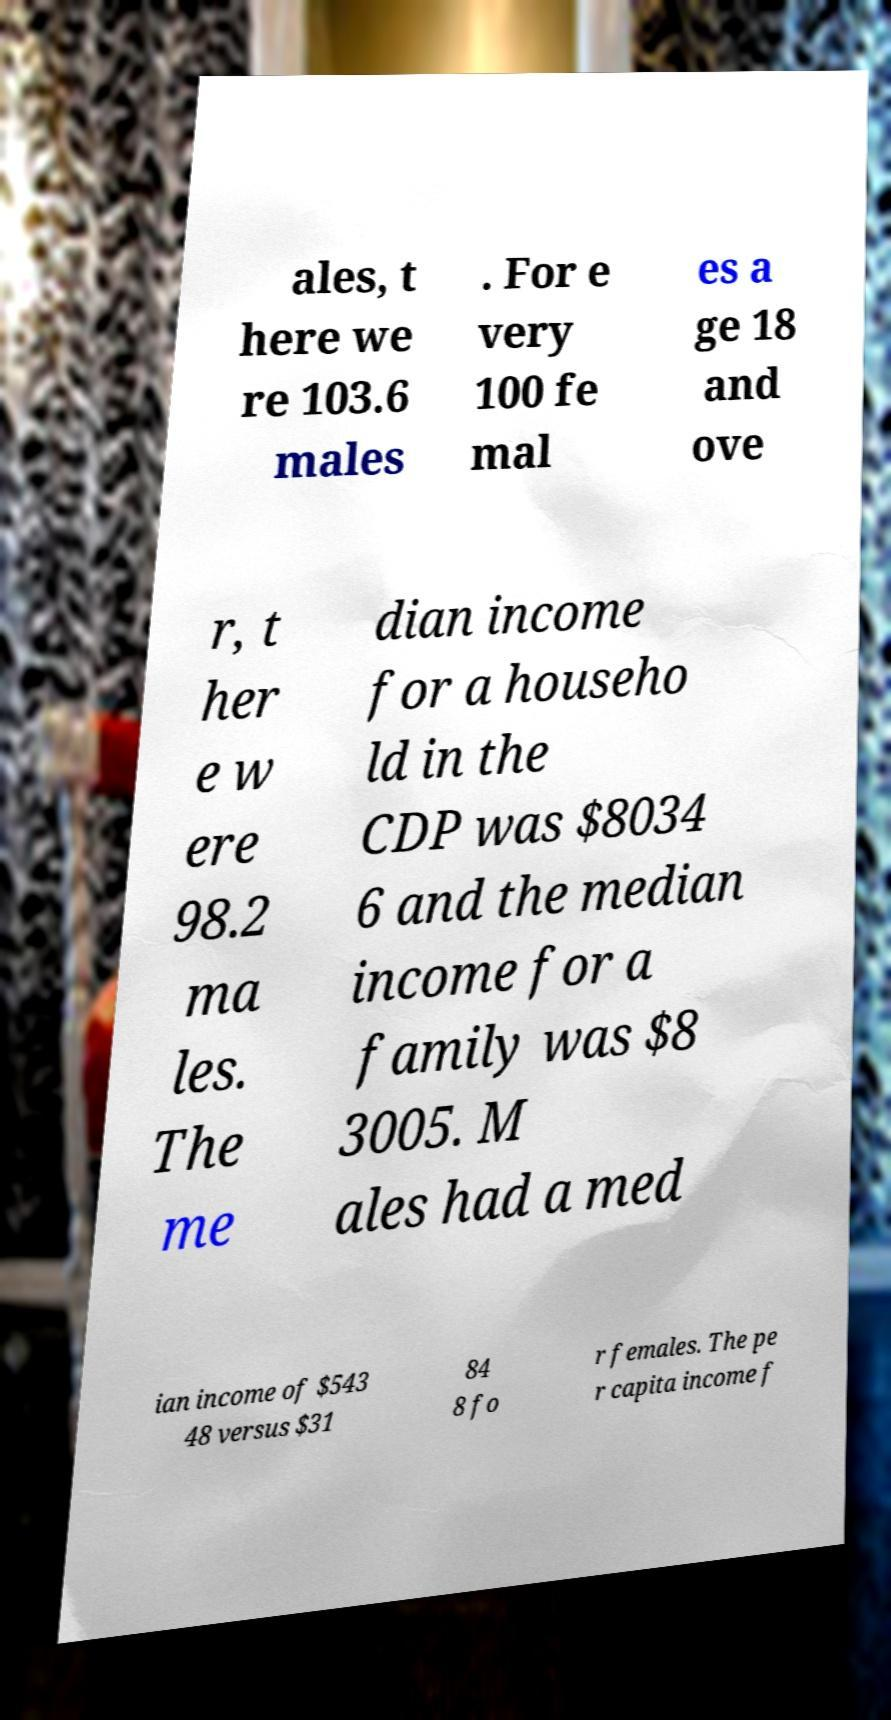Please read and relay the text visible in this image. What does it say? ales, t here we re 103.6 males . For e very 100 fe mal es a ge 18 and ove r, t her e w ere 98.2 ma les. The me dian income for a househo ld in the CDP was $8034 6 and the median income for a family was $8 3005. M ales had a med ian income of $543 48 versus $31 84 8 fo r females. The pe r capita income f 